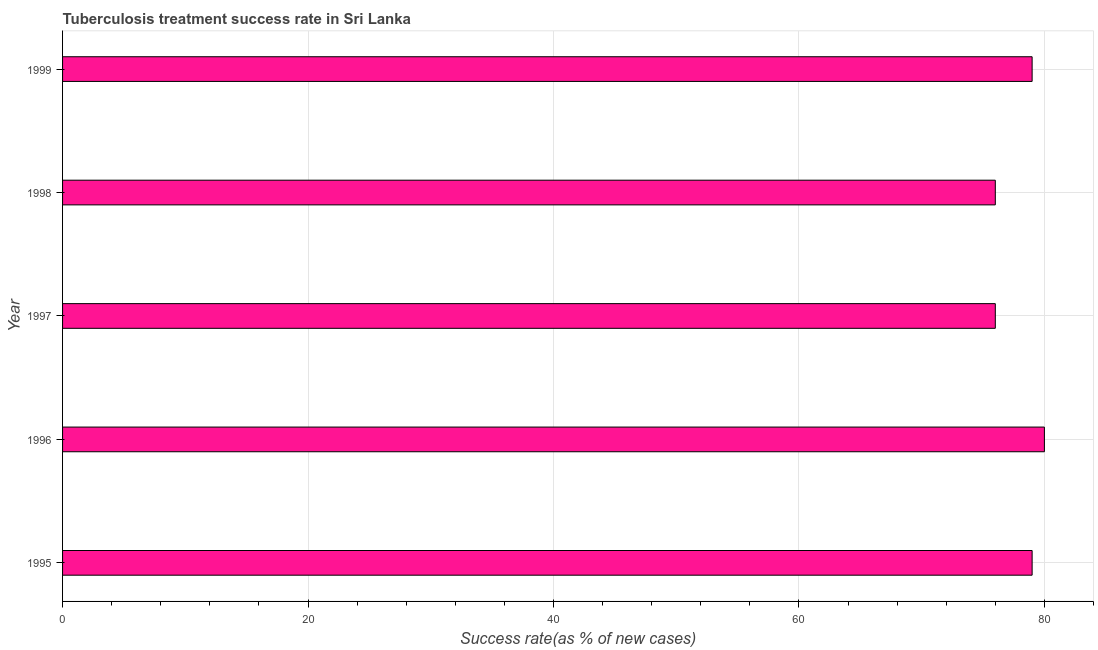Does the graph contain any zero values?
Keep it short and to the point. No. Does the graph contain grids?
Your answer should be compact. Yes. What is the title of the graph?
Give a very brief answer. Tuberculosis treatment success rate in Sri Lanka. What is the label or title of the X-axis?
Keep it short and to the point. Success rate(as % of new cases). What is the label or title of the Y-axis?
Offer a very short reply. Year. What is the tuberculosis treatment success rate in 1998?
Offer a terse response. 76. Across all years, what is the minimum tuberculosis treatment success rate?
Ensure brevity in your answer.  76. In which year was the tuberculosis treatment success rate maximum?
Keep it short and to the point. 1996. In which year was the tuberculosis treatment success rate minimum?
Ensure brevity in your answer.  1997. What is the sum of the tuberculosis treatment success rate?
Offer a terse response. 390. What is the difference between the tuberculosis treatment success rate in 1995 and 1999?
Provide a short and direct response. 0. What is the average tuberculosis treatment success rate per year?
Ensure brevity in your answer.  78. What is the median tuberculosis treatment success rate?
Your answer should be very brief. 79. In how many years, is the tuberculosis treatment success rate greater than 52 %?
Your answer should be very brief. 5. Is the tuberculosis treatment success rate in 1997 less than that in 1999?
Offer a very short reply. Yes. Is the difference between the tuberculosis treatment success rate in 1995 and 1997 greater than the difference between any two years?
Provide a succinct answer. No. What is the difference between the highest and the second highest tuberculosis treatment success rate?
Offer a terse response. 1. What is the difference between the highest and the lowest tuberculosis treatment success rate?
Your answer should be very brief. 4. Are all the bars in the graph horizontal?
Provide a succinct answer. Yes. What is the difference between two consecutive major ticks on the X-axis?
Your answer should be compact. 20. Are the values on the major ticks of X-axis written in scientific E-notation?
Ensure brevity in your answer.  No. What is the Success rate(as % of new cases) in 1995?
Give a very brief answer. 79. What is the Success rate(as % of new cases) in 1996?
Your answer should be very brief. 80. What is the Success rate(as % of new cases) in 1999?
Give a very brief answer. 79. What is the difference between the Success rate(as % of new cases) in 1995 and 1997?
Offer a very short reply. 3. What is the difference between the Success rate(as % of new cases) in 1996 and 1999?
Make the answer very short. 1. What is the difference between the Success rate(as % of new cases) in 1997 and 1998?
Make the answer very short. 0. What is the difference between the Success rate(as % of new cases) in 1998 and 1999?
Your response must be concise. -3. What is the ratio of the Success rate(as % of new cases) in 1995 to that in 1996?
Make the answer very short. 0.99. What is the ratio of the Success rate(as % of new cases) in 1995 to that in 1997?
Ensure brevity in your answer.  1.04. What is the ratio of the Success rate(as % of new cases) in 1995 to that in 1998?
Give a very brief answer. 1.04. What is the ratio of the Success rate(as % of new cases) in 1996 to that in 1997?
Your answer should be very brief. 1.05. What is the ratio of the Success rate(as % of new cases) in 1996 to that in 1998?
Give a very brief answer. 1.05. What is the ratio of the Success rate(as % of new cases) in 1997 to that in 1999?
Ensure brevity in your answer.  0.96. 